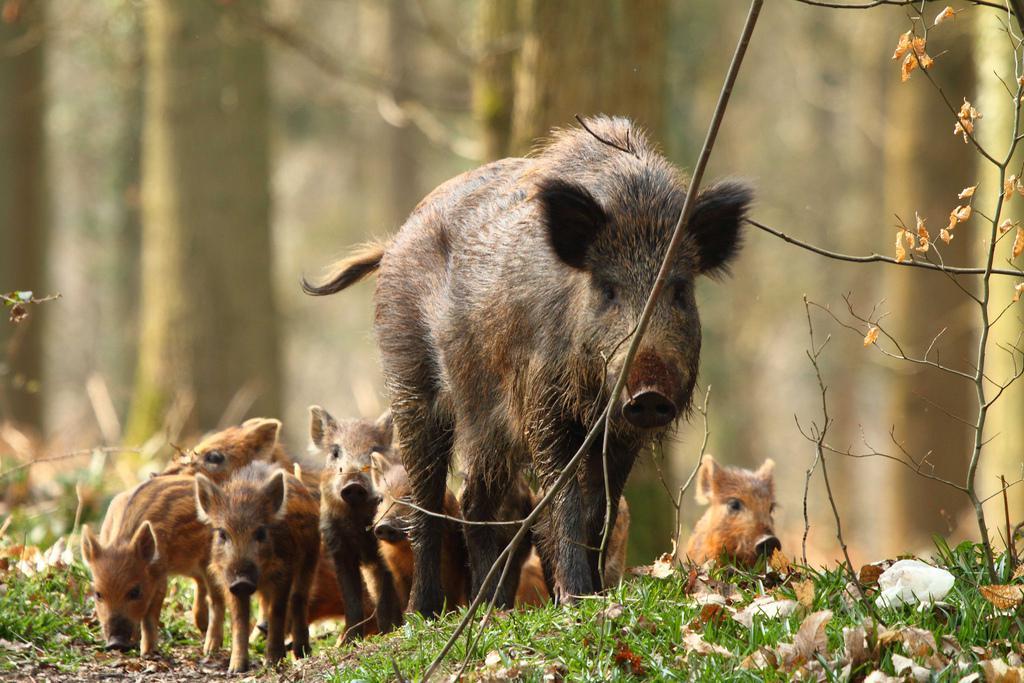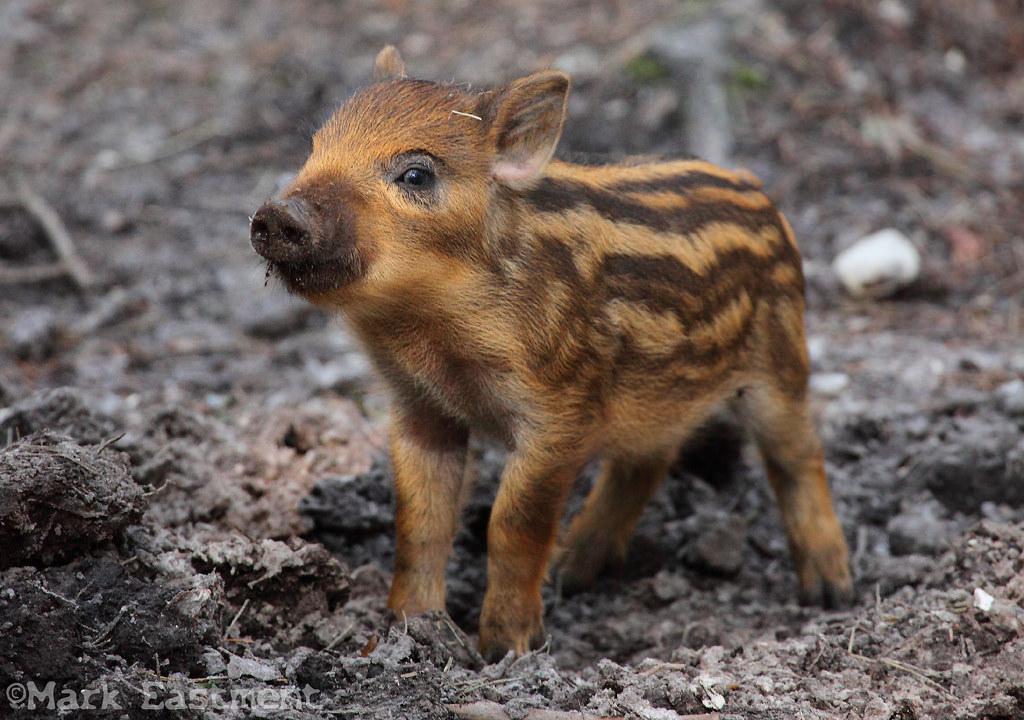The first image is the image on the left, the second image is the image on the right. Assess this claim about the two images: "An image shows just one striped baby wild pig, which is turned leftward and standing on brown ground.". Correct or not? Answer yes or no. Yes. The first image is the image on the left, the second image is the image on the right. For the images shown, is this caption "One of the animals in the image on the left is not striped." true? Answer yes or no. Yes. 